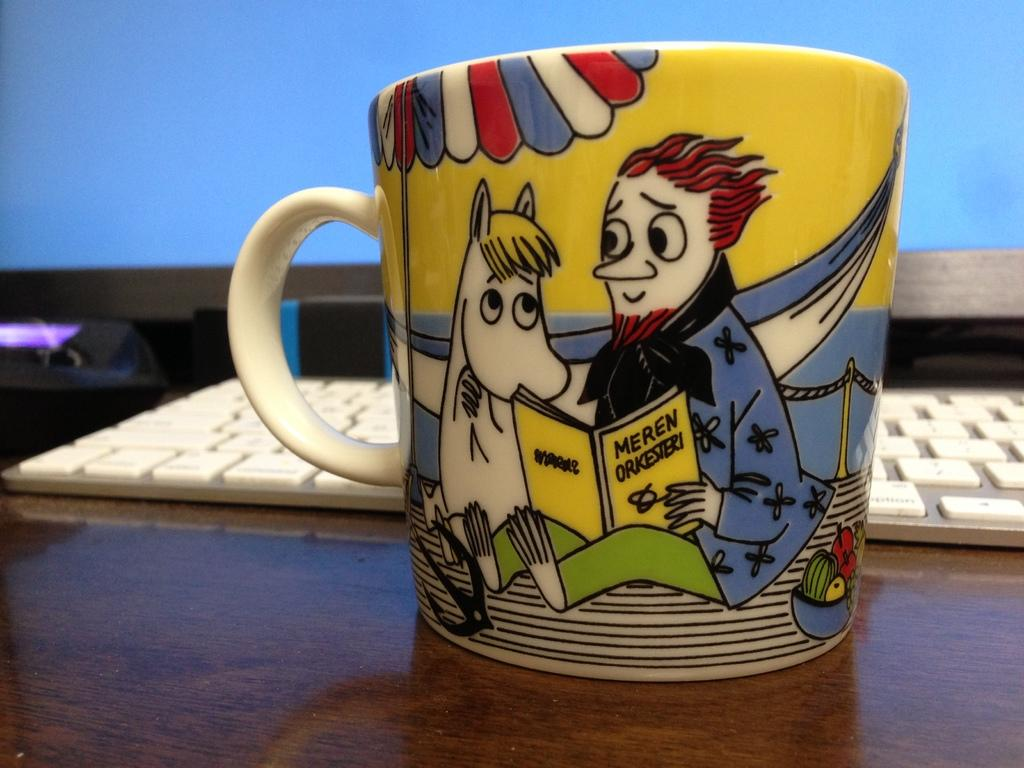Provide a one-sentence caption for the provided image. Cup showing a man reading to a horse with the book "Meren Orkesieri". 